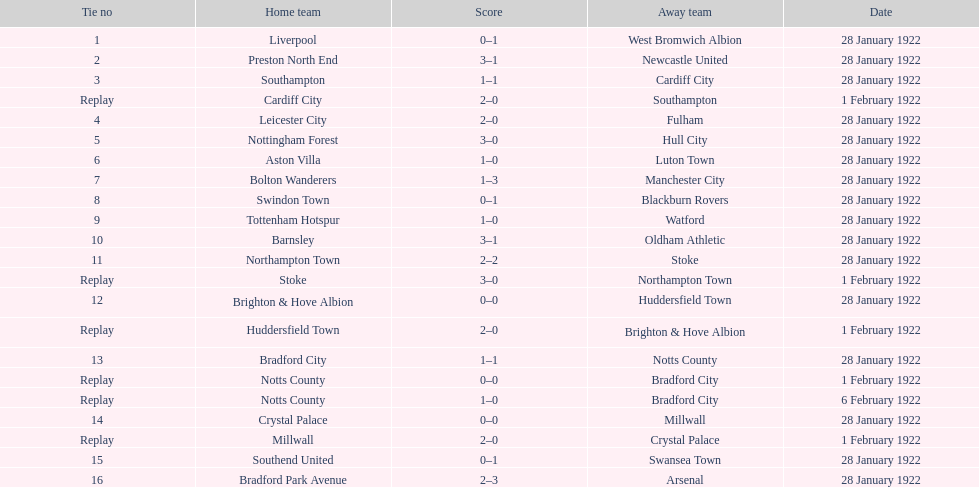What date did they play before feb 1? 28 January 1922. 